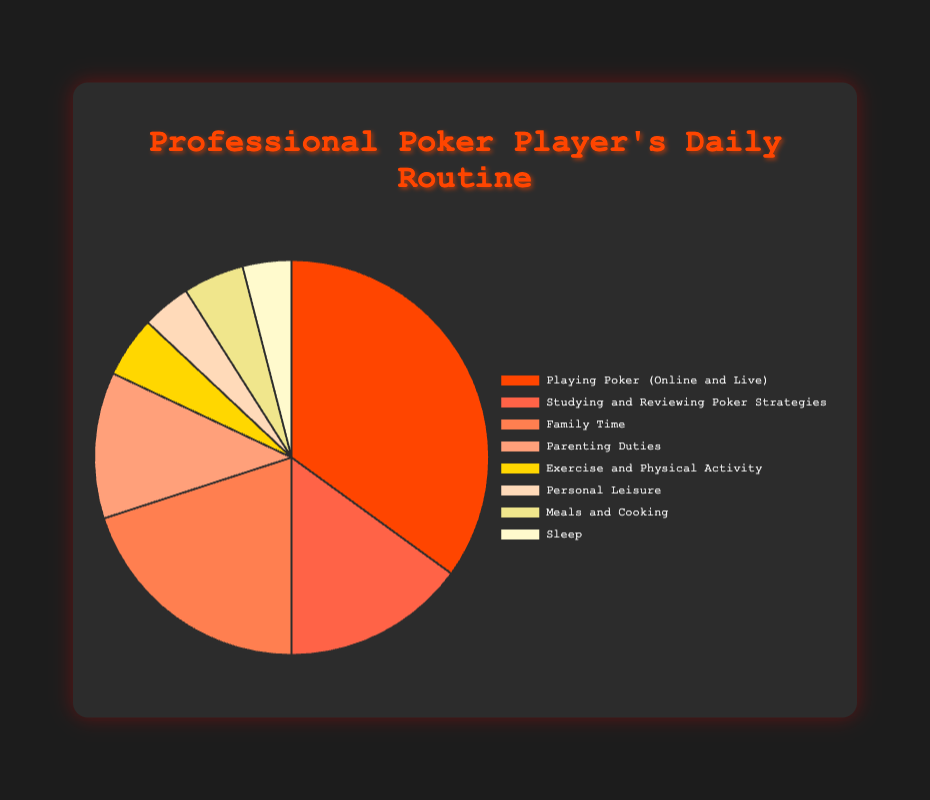What's the total percentage of time spent on activities related to poker (playing and studying)? To find the total percentage of time spent on activities related to poker, we add the percentages of "Playing Poker (Online and Live)" and "Studying and Reviewing Poker Strategies". That is 35% + 15% = 50%.
Answer: 50% What's the combined percentage of time spent on parenting duties and family time? To find the combined percentage, we add the percentages of "Parenting Duties" and "Family Time". That is 12% + 20% = 32%.
Answer: 32% Which activity takes up the most time in the daily routine? By looking at the chart, we can see that "Playing Poker (Online and Live)" has the highest percentage at 35%.
Answer: Playing Poker (Online and Live) What is the difference in time allocation between personal leisure and exercise and physical activity? Subtract the percentage of "Personal Leisure" from the percentage of "Exercise and Physical Activity". That is 5% - 4% = 1%.
Answer: 1% Which activity is represented by the color red in the pie chart? By referring to the visual attributes in the pie chart, the color red represents the activity "Playing Poker (Online and Live)".
Answer: Playing Poker (Online and Live) How much more time is spent on sleep compared to studying and reviewing poker strategies? Subtract the percentage of time spent on sleep (4%) from the percentage dedicated to studying and reviewing poker strategies (15%). That is 15% - 4% = 11%.
Answer: 11% Is the time spent on meals and cooking equal to the time spent on exercise and physical activity? By comparing the percentages for both activities, we see that each is allocated 5%. Therefore, the time spent is equal.
Answer: Yes What percentage of the day is spent on non-poker-related activities? To find this, we sum the percentages of all non-poker-related activities: "Family Time", "Parenting Duties", "Exercise and Physical Activity", "Personal Leisure", "Meals and Cooking", and "Sleep". That is 20% + 12% + 5% + 4% + 5% + 4% = 50%.
Answer: 50% What's the second most time-consuming activity in the daily routine? By comparing the percentages, we see that "Family Time" is the second most time-consuming activity at 20%.
Answer: Family Time 